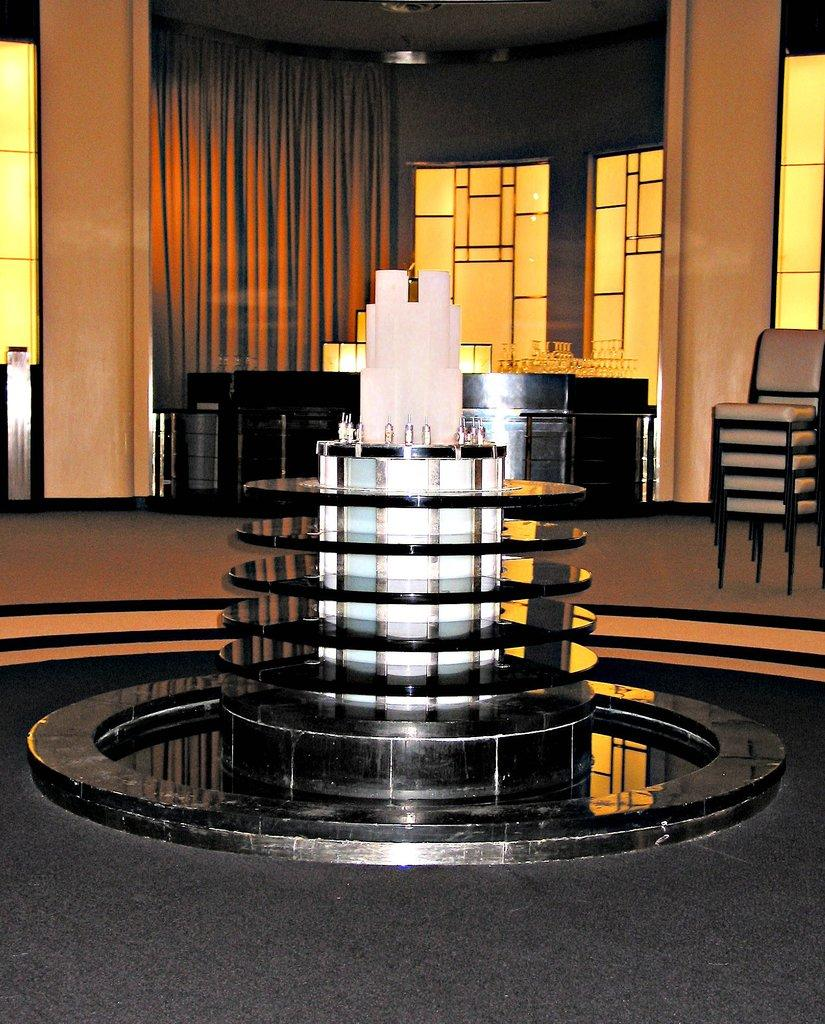What is the main feature in the front of the image? There is a fountain in the front of the image. What can be seen in the background of the image? There is a curtain and chairs in the background of the image. Are there any furniture items visible in the background? Yes, there is a table in the background of the image. What type of protest is taking place in the image? There is no protest present in the image; it features a fountain, curtain, chairs, and a table. What type of laborer is shown working in the image? There is no laborer present in the image. 